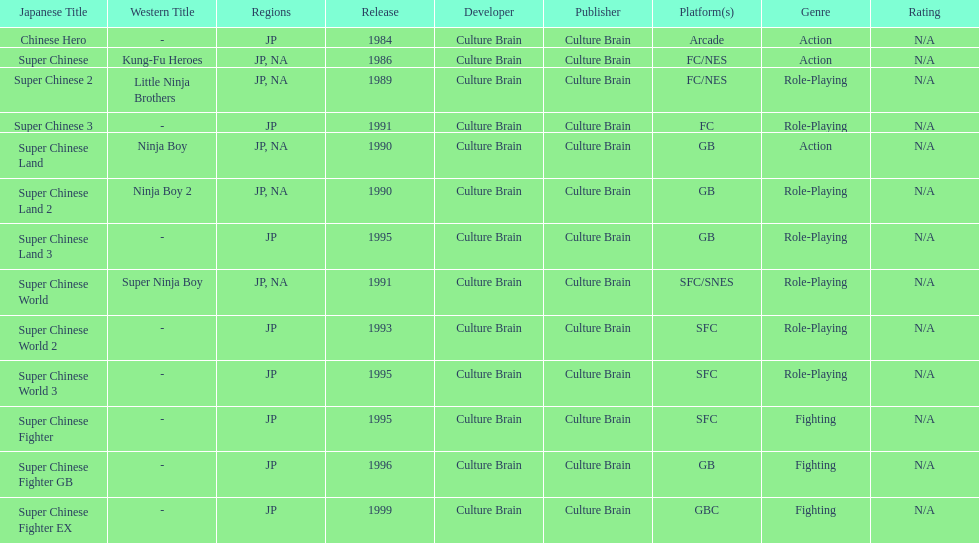How many action games were released in north america? 2. 